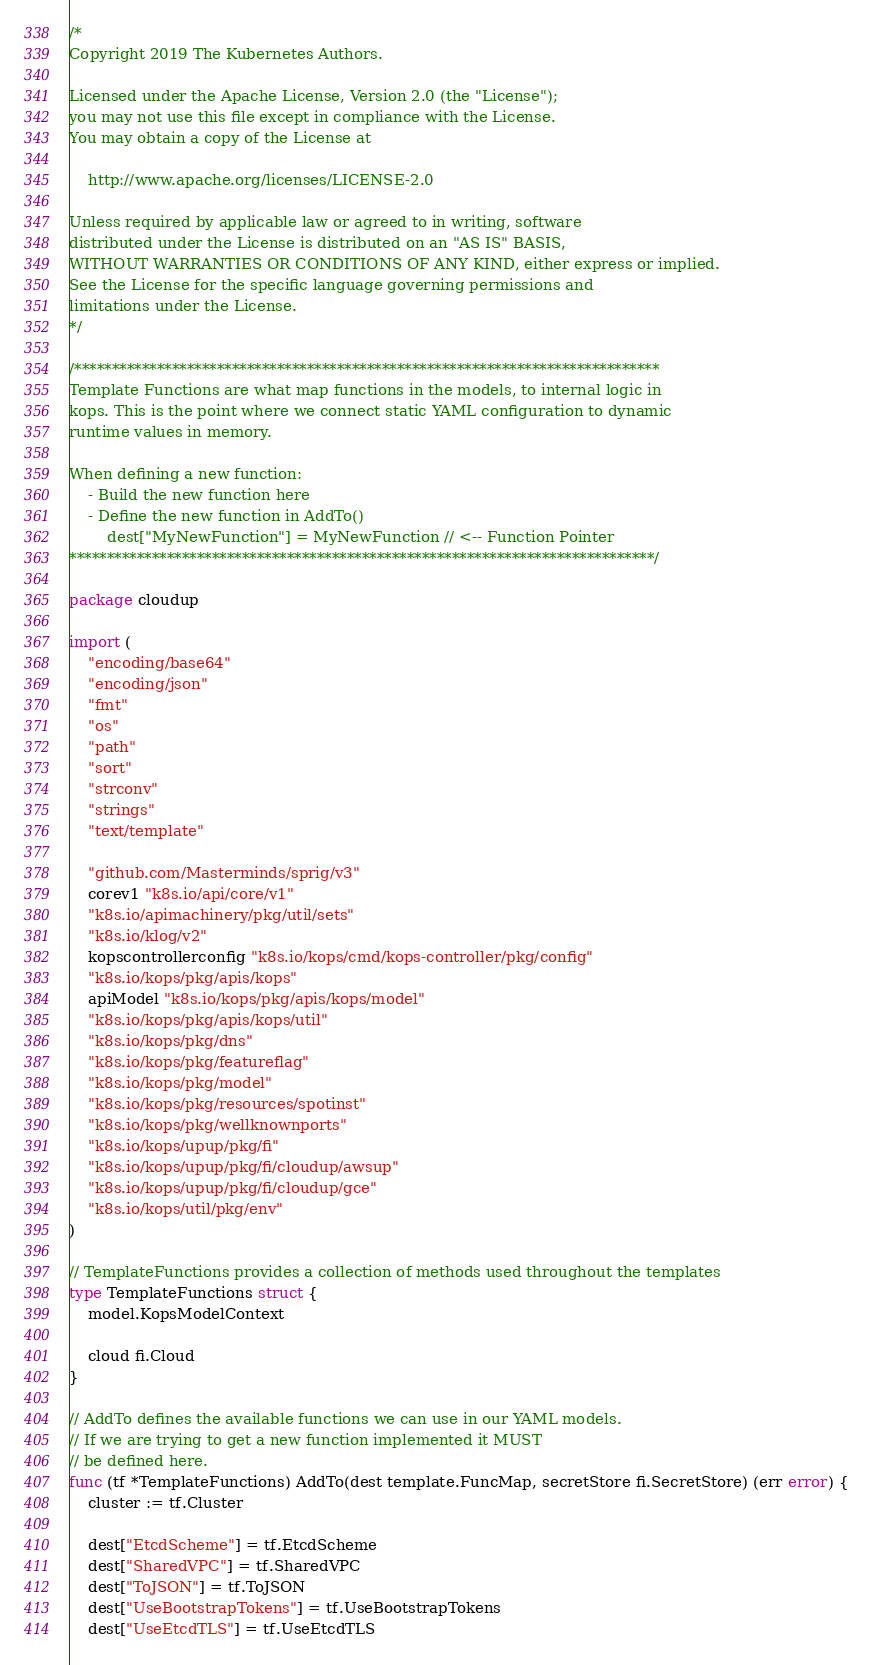Convert code to text. <code><loc_0><loc_0><loc_500><loc_500><_Go_>/*
Copyright 2019 The Kubernetes Authors.

Licensed under the Apache License, Version 2.0 (the "License");
you may not use this file except in compliance with the License.
You may obtain a copy of the License at

    http://www.apache.org/licenses/LICENSE-2.0

Unless required by applicable law or agreed to in writing, software
distributed under the License is distributed on an "AS IS" BASIS,
WITHOUT WARRANTIES OR CONDITIONS OF ANY KIND, either express or implied.
See the License for the specific language governing permissions and
limitations under the License.
*/

/******************************************************************************
Template Functions are what map functions in the models, to internal logic in
kops. This is the point where we connect static YAML configuration to dynamic
runtime values in memory.

When defining a new function:
	- Build the new function here
	- Define the new function in AddTo()
		dest["MyNewFunction"] = MyNewFunction // <-- Function Pointer
******************************************************************************/

package cloudup

import (
	"encoding/base64"
	"encoding/json"
	"fmt"
	"os"
	"path"
	"sort"
	"strconv"
	"strings"
	"text/template"

	"github.com/Masterminds/sprig/v3"
	corev1 "k8s.io/api/core/v1"
	"k8s.io/apimachinery/pkg/util/sets"
	"k8s.io/klog/v2"
	kopscontrollerconfig "k8s.io/kops/cmd/kops-controller/pkg/config"
	"k8s.io/kops/pkg/apis/kops"
	apiModel "k8s.io/kops/pkg/apis/kops/model"
	"k8s.io/kops/pkg/apis/kops/util"
	"k8s.io/kops/pkg/dns"
	"k8s.io/kops/pkg/featureflag"
	"k8s.io/kops/pkg/model"
	"k8s.io/kops/pkg/resources/spotinst"
	"k8s.io/kops/pkg/wellknownports"
	"k8s.io/kops/upup/pkg/fi"
	"k8s.io/kops/upup/pkg/fi/cloudup/awsup"
	"k8s.io/kops/upup/pkg/fi/cloudup/gce"
	"k8s.io/kops/util/pkg/env"
)

// TemplateFunctions provides a collection of methods used throughout the templates
type TemplateFunctions struct {
	model.KopsModelContext

	cloud fi.Cloud
}

// AddTo defines the available functions we can use in our YAML models.
// If we are trying to get a new function implemented it MUST
// be defined here.
func (tf *TemplateFunctions) AddTo(dest template.FuncMap, secretStore fi.SecretStore) (err error) {
	cluster := tf.Cluster

	dest["EtcdScheme"] = tf.EtcdScheme
	dest["SharedVPC"] = tf.SharedVPC
	dest["ToJSON"] = tf.ToJSON
	dest["UseBootstrapTokens"] = tf.UseBootstrapTokens
	dest["UseEtcdTLS"] = tf.UseEtcdTLS</code> 